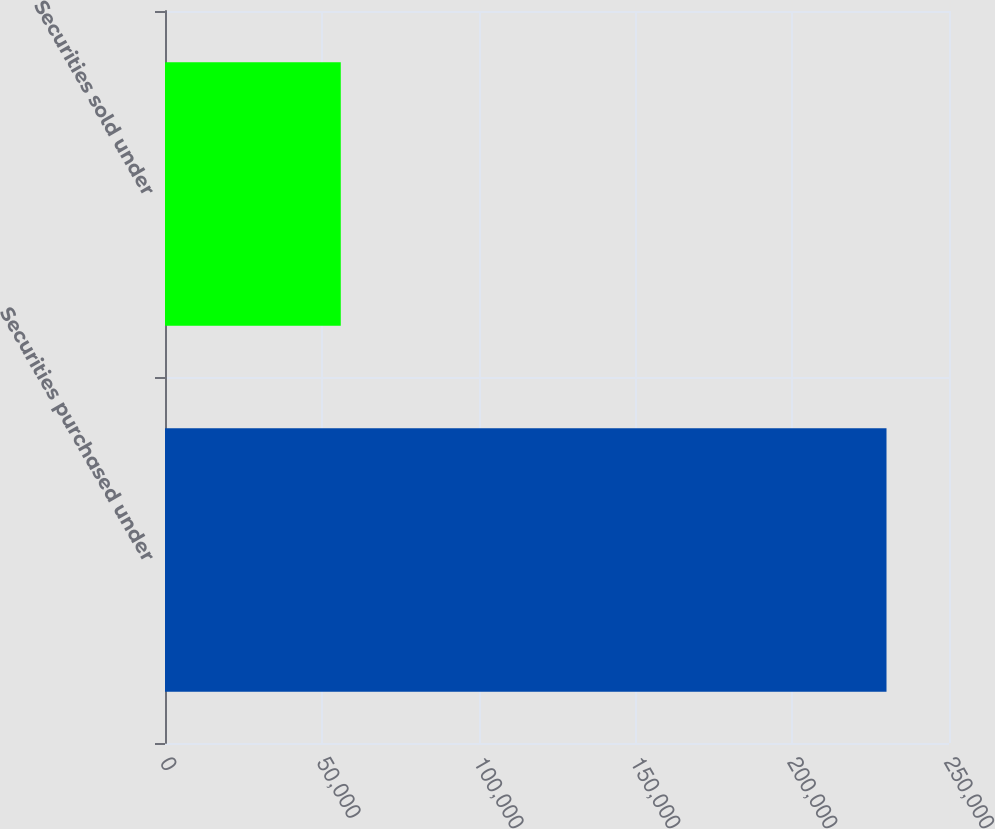Convert chart to OTSL. <chart><loc_0><loc_0><loc_500><loc_500><bar_chart><fcel>Securities purchased under<fcel>Securities sold under<nl><fcel>230073<fcel>56050<nl></chart> 